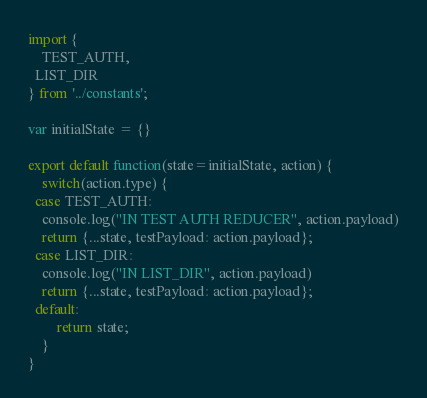Convert code to text. <code><loc_0><loc_0><loc_500><loc_500><_JavaScript_>import {
	TEST_AUTH,
  LIST_DIR
} from '../constants';

var initialState = {}

export default function(state=initialState, action) {
	switch(action.type) {
  case TEST_AUTH:
    console.log("IN TEST AUTH REDUCER", action.payload)
    return {...state, testPayload: action.payload};
  case LIST_DIR:
    console.log("IN LIST_DIR", action.payload)
    return {...state, testPayload: action.payload};
  default:
		return state;
	}
}
</code> 